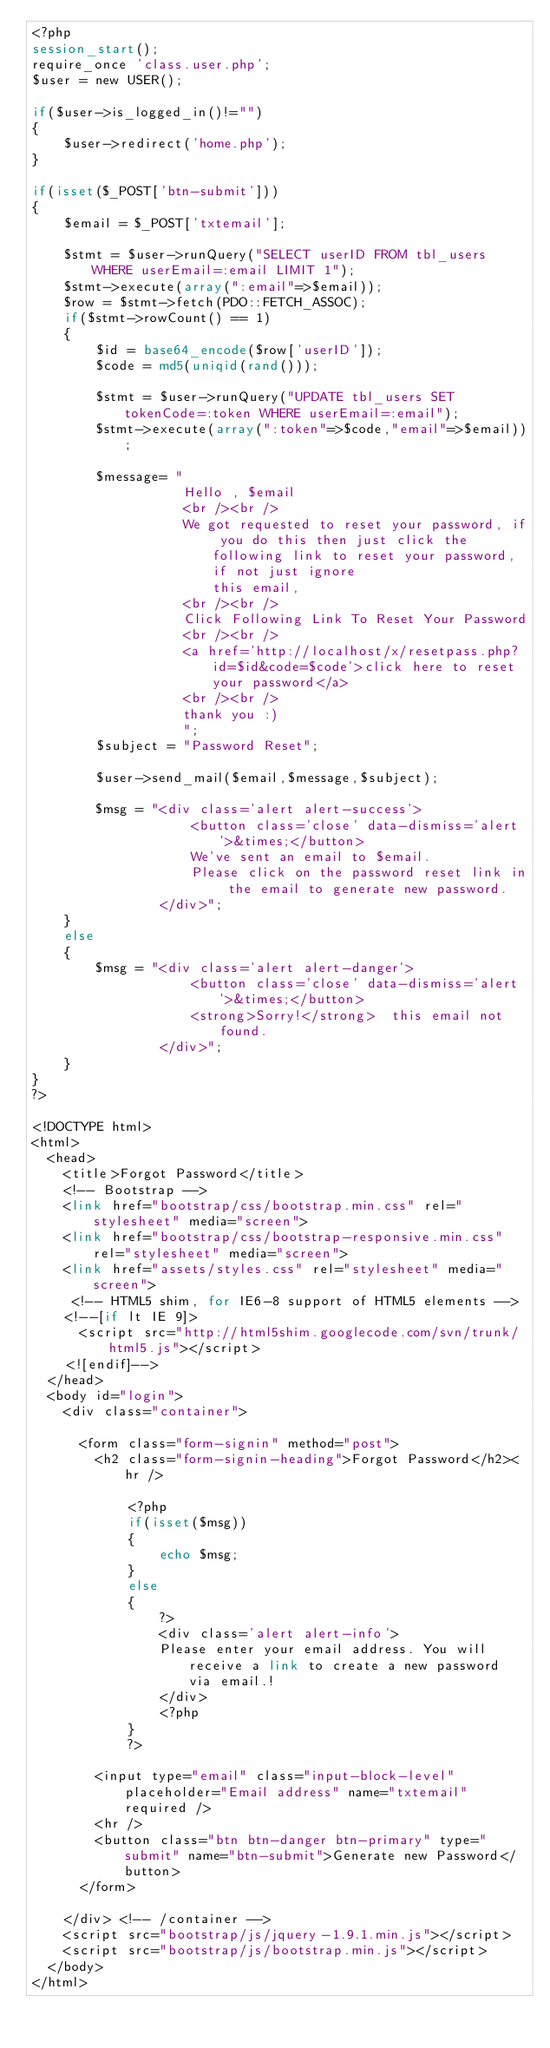<code> <loc_0><loc_0><loc_500><loc_500><_PHP_><?php
session_start();
require_once 'class.user.php';
$user = new USER();

if($user->is_logged_in()!="")
{
	$user->redirect('home.php');
}

if(isset($_POST['btn-submit']))
{
	$email = $_POST['txtemail'];
	
	$stmt = $user->runQuery("SELECT userID FROM tbl_users WHERE userEmail=:email LIMIT 1");
	$stmt->execute(array(":email"=>$email));
	$row = $stmt->fetch(PDO::FETCH_ASSOC);	
	if($stmt->rowCount() == 1)
	{
		$id = base64_encode($row['userID']);
		$code = md5(uniqid(rand()));
		
		$stmt = $user->runQuery("UPDATE tbl_users SET tokenCode=:token WHERE userEmail=:email");
		$stmt->execute(array(":token"=>$code,"email"=>$email));
		
		$message= "
				   Hello , $email
				   <br /><br />
				   We got requested to reset your password, if you do this then just click the following link to reset your password, if not just ignore                   this email,
				   <br /><br />
				   Click Following Link To Reset Your Password 
				   <br /><br />
				   <a href='http://localhost/x/resetpass.php?id=$id&code=$code'>click here to reset your password</a>
				   <br /><br />
				   thank you :)
				   ";
		$subject = "Password Reset";
		
		$user->send_mail($email,$message,$subject);
		
		$msg = "<div class='alert alert-success'>
					<button class='close' data-dismiss='alert'>&times;</button>
					We've sent an email to $email.
                    Please click on the password reset link in the email to generate new password. 
			  	</div>";
	}
	else
	{
		$msg = "<div class='alert alert-danger'>
					<button class='close' data-dismiss='alert'>&times;</button>
					<strong>Sorry!</strong>  this email not found. 
			    </div>";
	}
}
?>

<!DOCTYPE html>
<html>
  <head>
    <title>Forgot Password</title>
    <!-- Bootstrap -->
    <link href="bootstrap/css/bootstrap.min.css" rel="stylesheet" media="screen">
    <link href="bootstrap/css/bootstrap-responsive.min.css" rel="stylesheet" media="screen">
    <link href="assets/styles.css" rel="stylesheet" media="screen">
     <!-- HTML5 shim, for IE6-8 support of HTML5 elements -->
    <!--[if lt IE 9]>
      <script src="http://html5shim.googlecode.com/svn/trunk/html5.js"></script>
    <![endif]-->
  </head>
  <body id="login">
    <div class="container">

      <form class="form-signin" method="post">
        <h2 class="form-signin-heading">Forgot Password</h2><hr />
        
        	<?php
			if(isset($msg))
			{
				echo $msg;
			}
			else
			{
				?>
              	<div class='alert alert-info'>
				Please enter your email address. You will receive a link to create a new password via email.!
				</div>  
                <?php
			}
			?>
        
        <input type="email" class="input-block-level" placeholder="Email address" name="txtemail" required />
     	<hr />
        <button class="btn btn-danger btn-primary" type="submit" name="btn-submit">Generate new Password</button>
      </form>

    </div> <!-- /container -->
    <script src="bootstrap/js/jquery-1.9.1.min.js"></script>
    <script src="bootstrap/js/bootstrap.min.js"></script>
  </body>
</html></code> 